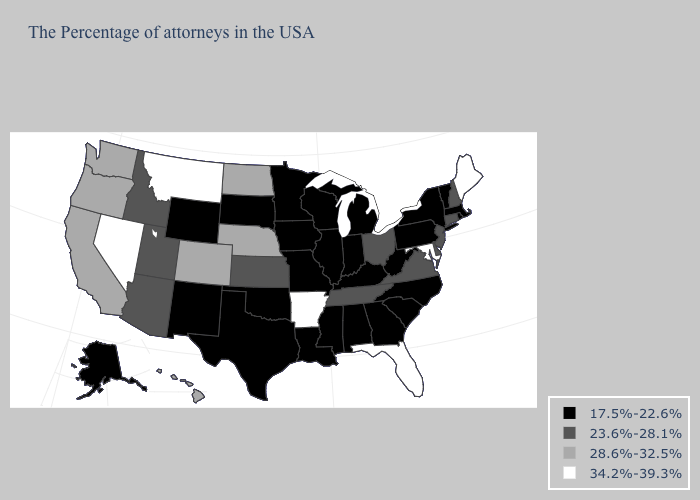Which states hav the highest value in the West?
Quick response, please. Montana, Nevada. Name the states that have a value in the range 17.5%-22.6%?
Concise answer only. Massachusetts, Rhode Island, Vermont, New York, Pennsylvania, North Carolina, South Carolina, West Virginia, Georgia, Michigan, Kentucky, Indiana, Alabama, Wisconsin, Illinois, Mississippi, Louisiana, Missouri, Minnesota, Iowa, Oklahoma, Texas, South Dakota, Wyoming, New Mexico, Alaska. Name the states that have a value in the range 28.6%-32.5%?
Be succinct. Nebraska, North Dakota, Colorado, California, Washington, Oregon, Hawaii. Which states have the lowest value in the USA?
Concise answer only. Massachusetts, Rhode Island, Vermont, New York, Pennsylvania, North Carolina, South Carolina, West Virginia, Georgia, Michigan, Kentucky, Indiana, Alabama, Wisconsin, Illinois, Mississippi, Louisiana, Missouri, Minnesota, Iowa, Oklahoma, Texas, South Dakota, Wyoming, New Mexico, Alaska. What is the highest value in the Northeast ?
Be succinct. 34.2%-39.3%. Name the states that have a value in the range 17.5%-22.6%?
Be succinct. Massachusetts, Rhode Island, Vermont, New York, Pennsylvania, North Carolina, South Carolina, West Virginia, Georgia, Michigan, Kentucky, Indiana, Alabama, Wisconsin, Illinois, Mississippi, Louisiana, Missouri, Minnesota, Iowa, Oklahoma, Texas, South Dakota, Wyoming, New Mexico, Alaska. Name the states that have a value in the range 28.6%-32.5%?
Write a very short answer. Nebraska, North Dakota, Colorado, California, Washington, Oregon, Hawaii. Which states have the lowest value in the USA?
Write a very short answer. Massachusetts, Rhode Island, Vermont, New York, Pennsylvania, North Carolina, South Carolina, West Virginia, Georgia, Michigan, Kentucky, Indiana, Alabama, Wisconsin, Illinois, Mississippi, Louisiana, Missouri, Minnesota, Iowa, Oklahoma, Texas, South Dakota, Wyoming, New Mexico, Alaska. Does the map have missing data?
Keep it brief. No. Does the first symbol in the legend represent the smallest category?
Give a very brief answer. Yes. How many symbols are there in the legend?
Short answer required. 4. Name the states that have a value in the range 28.6%-32.5%?
Be succinct. Nebraska, North Dakota, Colorado, California, Washington, Oregon, Hawaii. Does the first symbol in the legend represent the smallest category?
Concise answer only. Yes. Name the states that have a value in the range 17.5%-22.6%?
Answer briefly. Massachusetts, Rhode Island, Vermont, New York, Pennsylvania, North Carolina, South Carolina, West Virginia, Georgia, Michigan, Kentucky, Indiana, Alabama, Wisconsin, Illinois, Mississippi, Louisiana, Missouri, Minnesota, Iowa, Oklahoma, Texas, South Dakota, Wyoming, New Mexico, Alaska. Does Maine have the highest value in the USA?
Be succinct. Yes. 